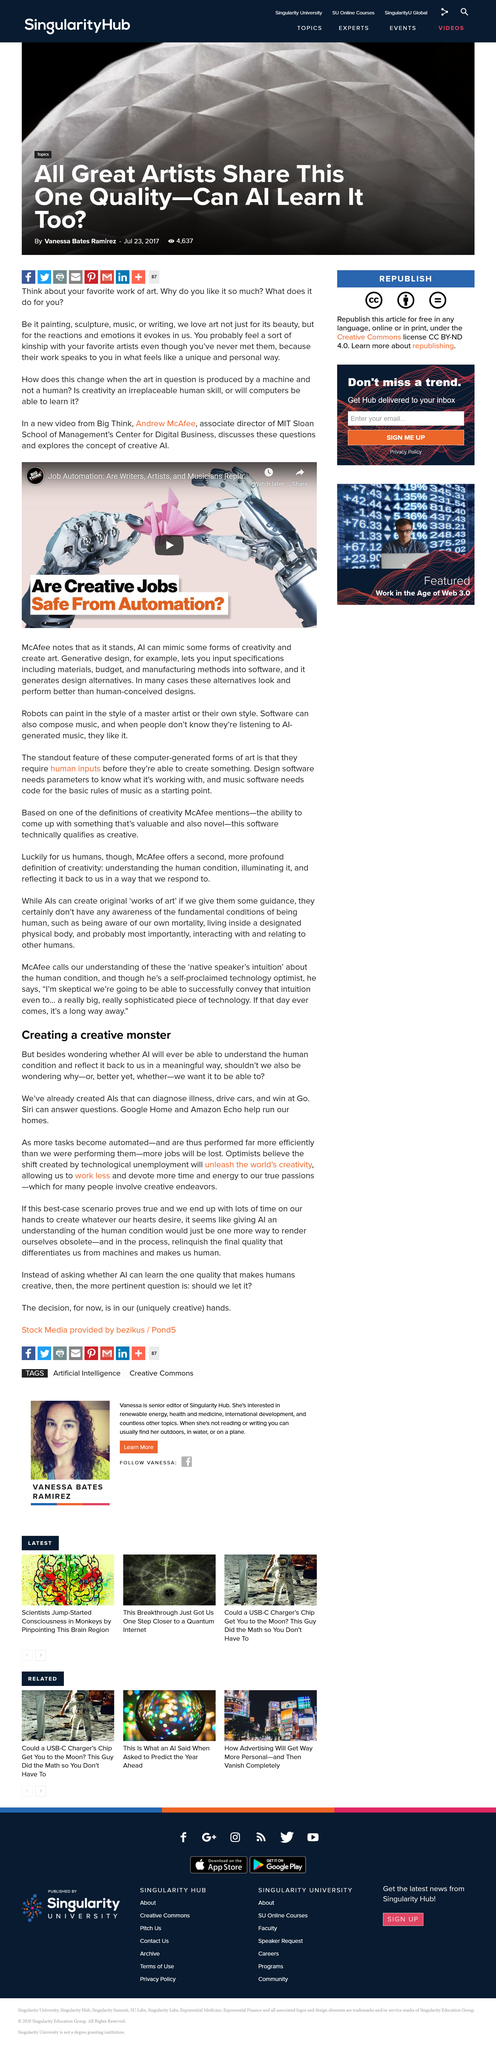Specify some key components in this picture. AIs are currently capable of diagnosing illnesses. I declare that the new video was created by the channel named Big Think. Optimists believe that automation will unleash creativity in the world. Andrew McAfee is the associate director of the MIT Sloan School of Management. Google Home and Amazon Echo are AI-powered devices that help individuals run their homes by providing a variety of services and functions. 